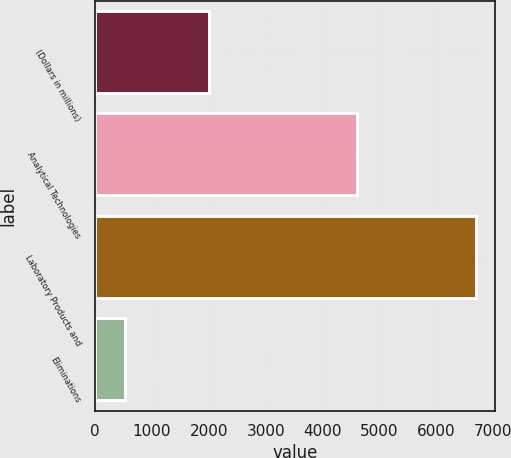Convert chart to OTSL. <chart><loc_0><loc_0><loc_500><loc_500><bar_chart><fcel>(Dollars in millions)<fcel>Analytical Technologies<fcel>Laboratory Products and<fcel>Eliminations<nl><fcel>2010<fcel>4611.8<fcel>6693<fcel>516.1<nl></chart> 